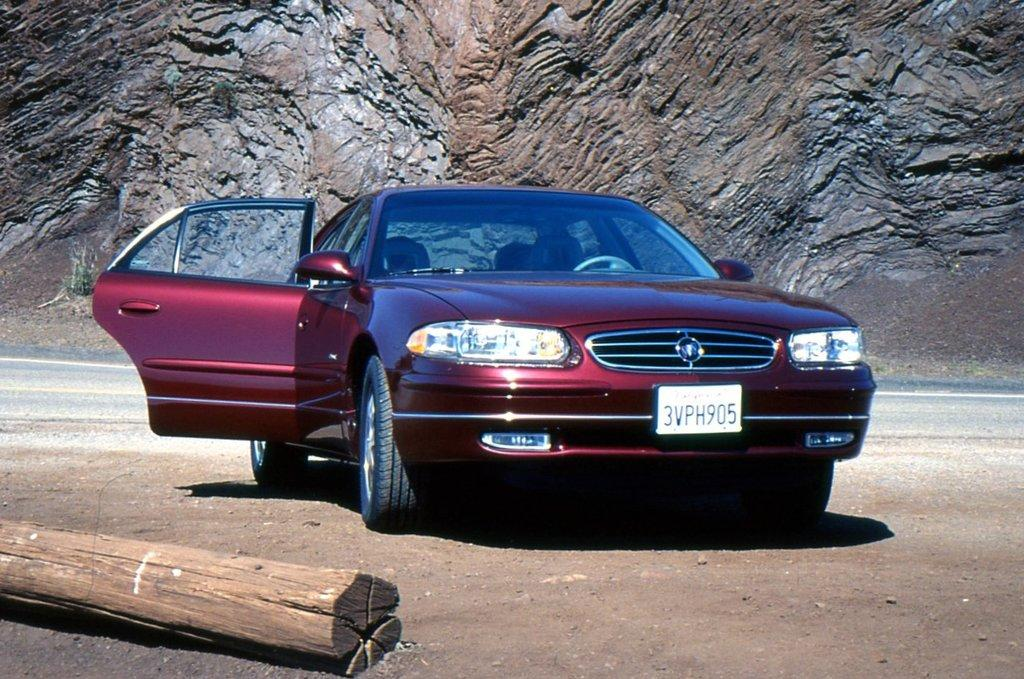What is the main subject of the image? There is a car in the image. Can you describe any specific features of the car? The car has a number plate and the car door is opened. What is located on the left side of the image? There is a wooden log on the left side of the image. What can be seen in the background of the image? There is a rock wall in the background of the image, and a road is near the rock wall. How does the actor express anger in the image? There is no actor present in the image, and therefore no expression of anger can be observed. What type of cough is the wooden log causing in the image? There is no cough present in the image, as the wooden log is an inanimate object and cannot cause a cough. 